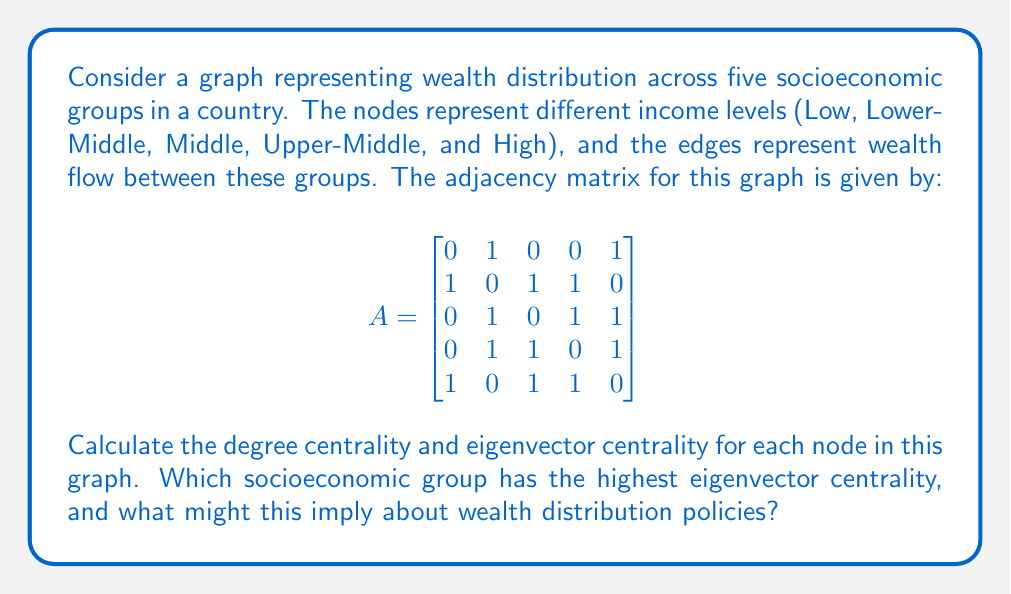Solve this math problem. To solve this problem, we'll follow these steps:

1. Calculate the degree centrality for each node
2. Calculate the eigenvector centrality for each node
3. Interpret the results

Step 1: Degree Centrality

The degree centrality of a node is the number of edges connected to it. We can calculate this by summing the rows (or columns) of the adjacency matrix.

Low: $2$
Lower-Middle: $3$
Middle: $3$
Upper-Middle: $3$
High: $3$

Step 2: Eigenvector Centrality

Eigenvector centrality is a measure of the influence of a node in a network. It assigns relative scores to all nodes based on the concept that connections to high-scoring nodes contribute more to the score of the node in question than equal connections to low-scoring nodes.

To calculate eigenvector centrality:

a) Find the largest eigenvalue ($\lambda$) and its corresponding eigenvector of the adjacency matrix.
b) Normalize the eigenvector so that the sum of all elements equals 1.

Using a mathematical software or calculator, we find:

Largest eigenvalue: $\lambda \approx 2.4815$

Corresponding eigenvector:
$$
\vec{v} \approx \begin{bmatrix}
0.3249 \\
0.5244 \\
0.4781 \\
0.4781 \\
0.3249
\end{bmatrix}
$$

Normalizing this vector (dividing by the sum of its elements):

$$
\vec{v}_{\text{normalized}} \approx \begin{bmatrix}
0.1524 \\
0.2459 \\
0.2242 \\
0.2242 \\
0.1524
\end{bmatrix}
$$

Step 3: Interpretation

The Lower-Middle income group has the highest eigenvector centrality (0.2459). This implies that this group has the most influence on wealth distribution in the network.

For a political science student interested in government policies and wealth distribution, this result suggests that policies targeting the Lower-Middle income group might have the most significant impact on overall wealth distribution. This could be due to the group's central position in the economic structure, potentially acting as a bridge between lower and higher income groups.

The high centrality of the Lower-Middle income group might also indicate that this group is most vulnerable to economic shocks or most responsive to policy changes. Therefore, policies aimed at strengthening this group, such as education and skill development programs, could have far-reaching effects on the entire economic structure.
Answer: Degree Centrality:
Low: 2, Lower-Middle: 3, Middle: 3, Upper-Middle: 3, High: 3

Eigenvector Centrality:
Low: 0.1524, Lower-Middle: 0.2459, Middle: 0.2242, Upper-Middle: 0.2242, High: 0.1524

The Lower-Middle income group has the highest eigenvector centrality (0.2459), suggesting it has the most influence on wealth distribution in the network. This implies that policies targeting this group might have the most significant impact on overall wealth distribution. 